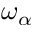Convert formula to latex. <formula><loc_0><loc_0><loc_500><loc_500>\omega _ { \alpha }</formula> 